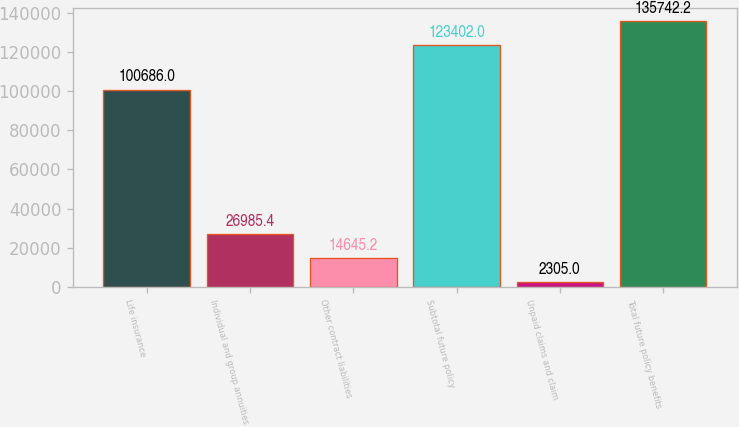Convert chart to OTSL. <chart><loc_0><loc_0><loc_500><loc_500><bar_chart><fcel>Life insurance<fcel>Individual and group annuities<fcel>Other contract liabilities<fcel>Subtotal future policy<fcel>Unpaid claims and claim<fcel>Total future policy benefits<nl><fcel>100686<fcel>26985.4<fcel>14645.2<fcel>123402<fcel>2305<fcel>135742<nl></chart> 